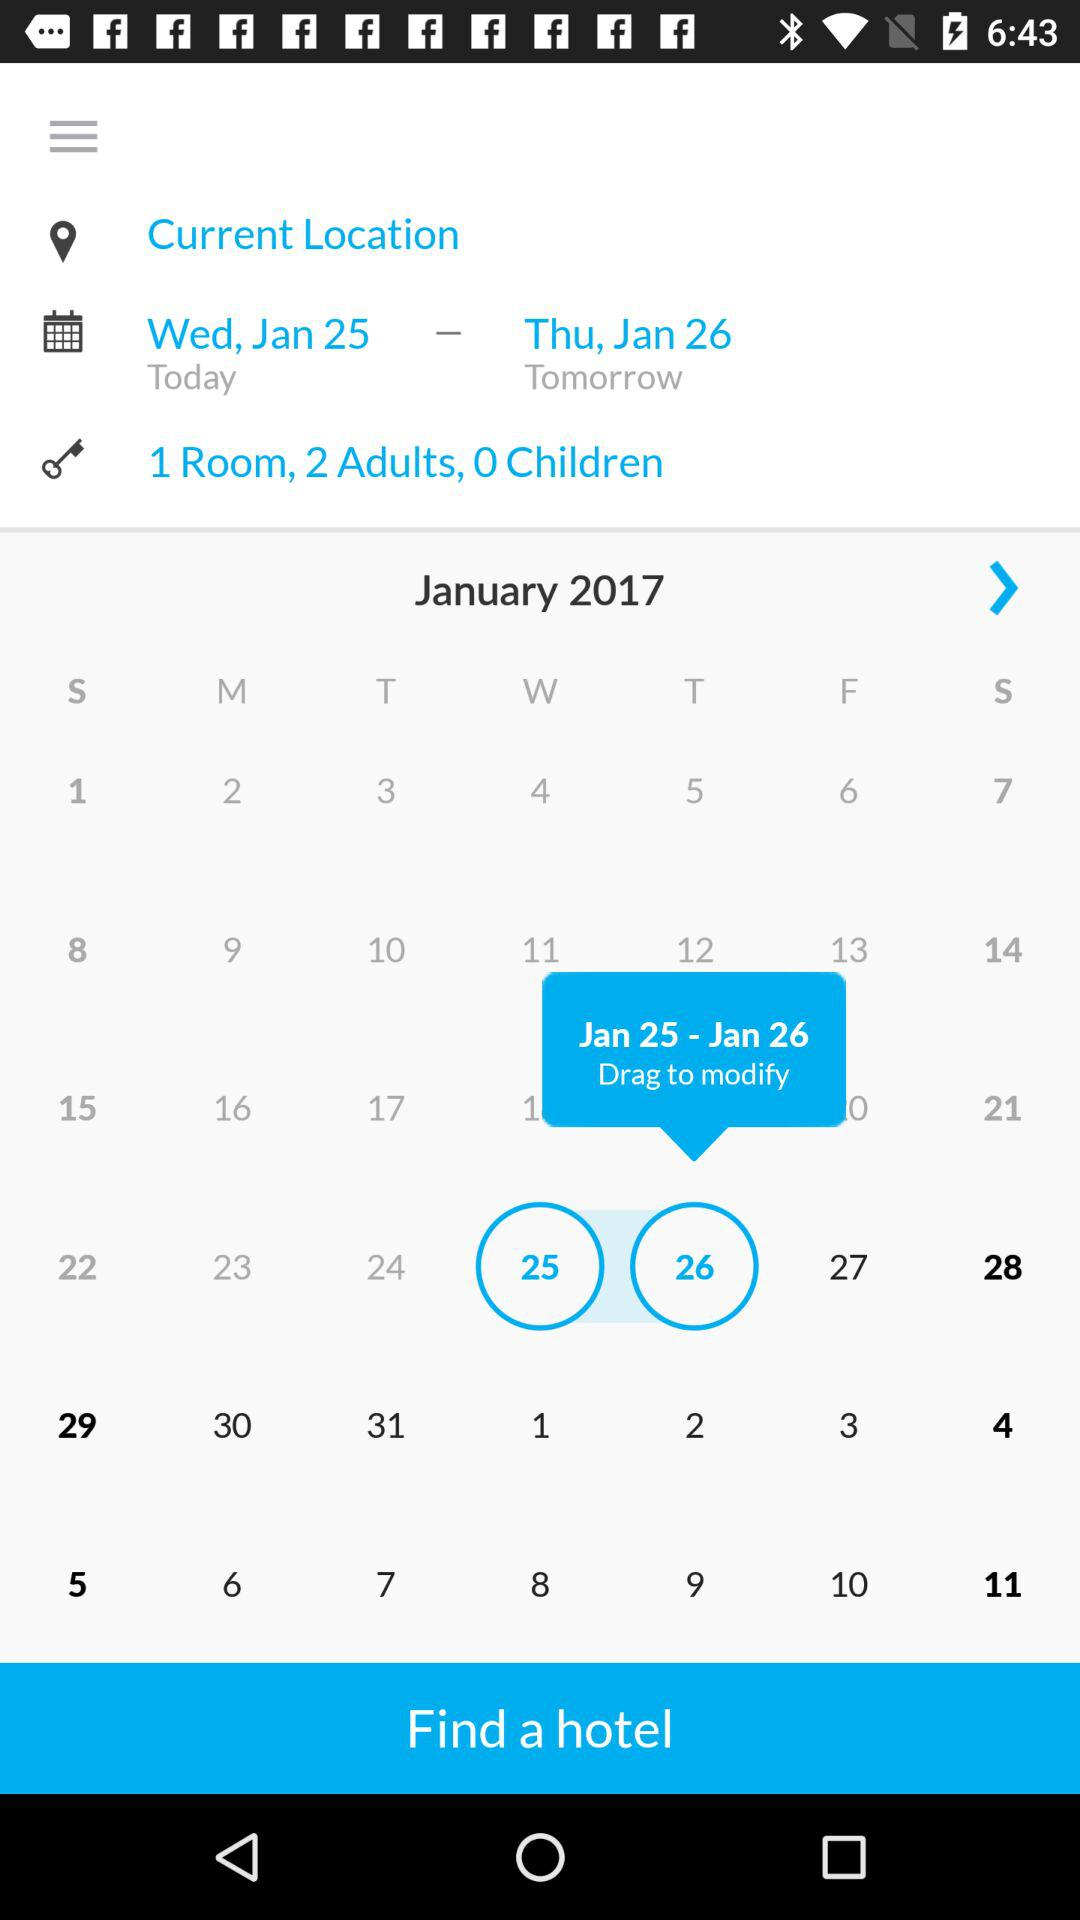How many adults are in 1 room? There are 2 adults. 